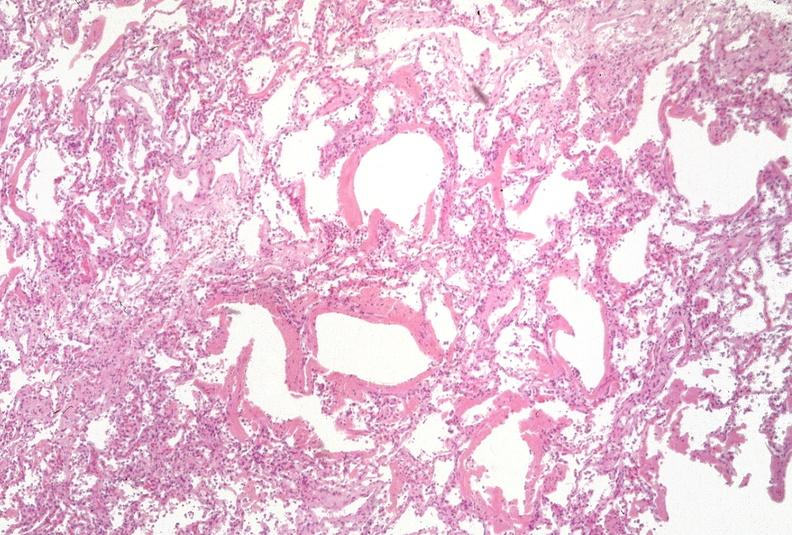what is present?
Answer the question using a single word or phrase. Respiratory 